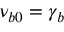Convert formula to latex. <formula><loc_0><loc_0><loc_500><loc_500>\nu _ { b 0 } = \gamma _ { b }</formula> 